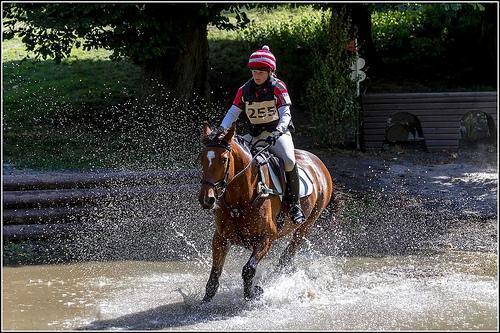How many horses are visible in the photo?
Give a very brief answer. 1. How many horses have no rider?
Give a very brief answer. 0. 